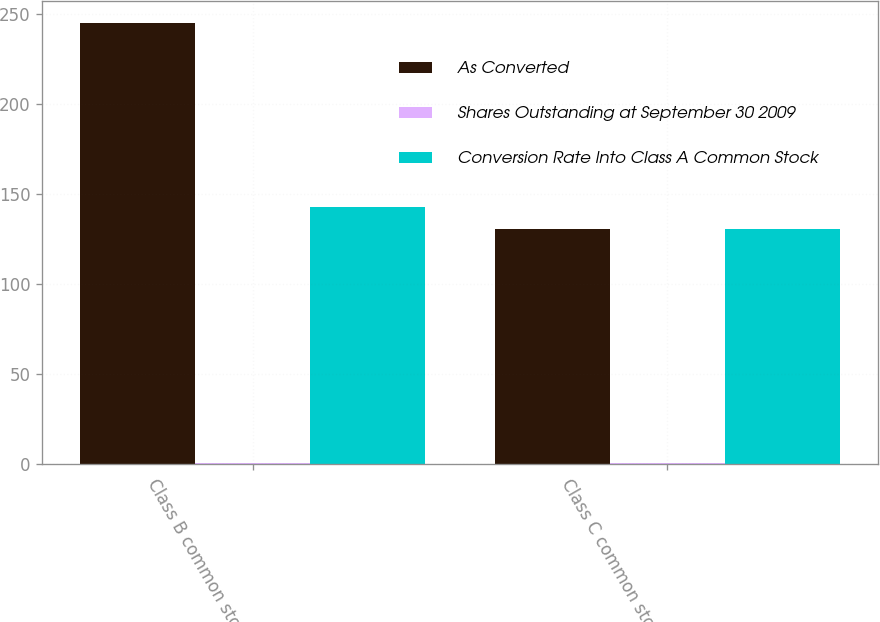Convert chart. <chart><loc_0><loc_0><loc_500><loc_500><stacked_bar_chart><ecel><fcel>Class B common stock<fcel>Class C common stock<nl><fcel>As Converted<fcel>245<fcel>131<nl><fcel>Shares Outstanding at September 30 2009<fcel>0.58<fcel>1<nl><fcel>Conversion Rate Into Class A Common Stock<fcel>143<fcel>131<nl></chart> 